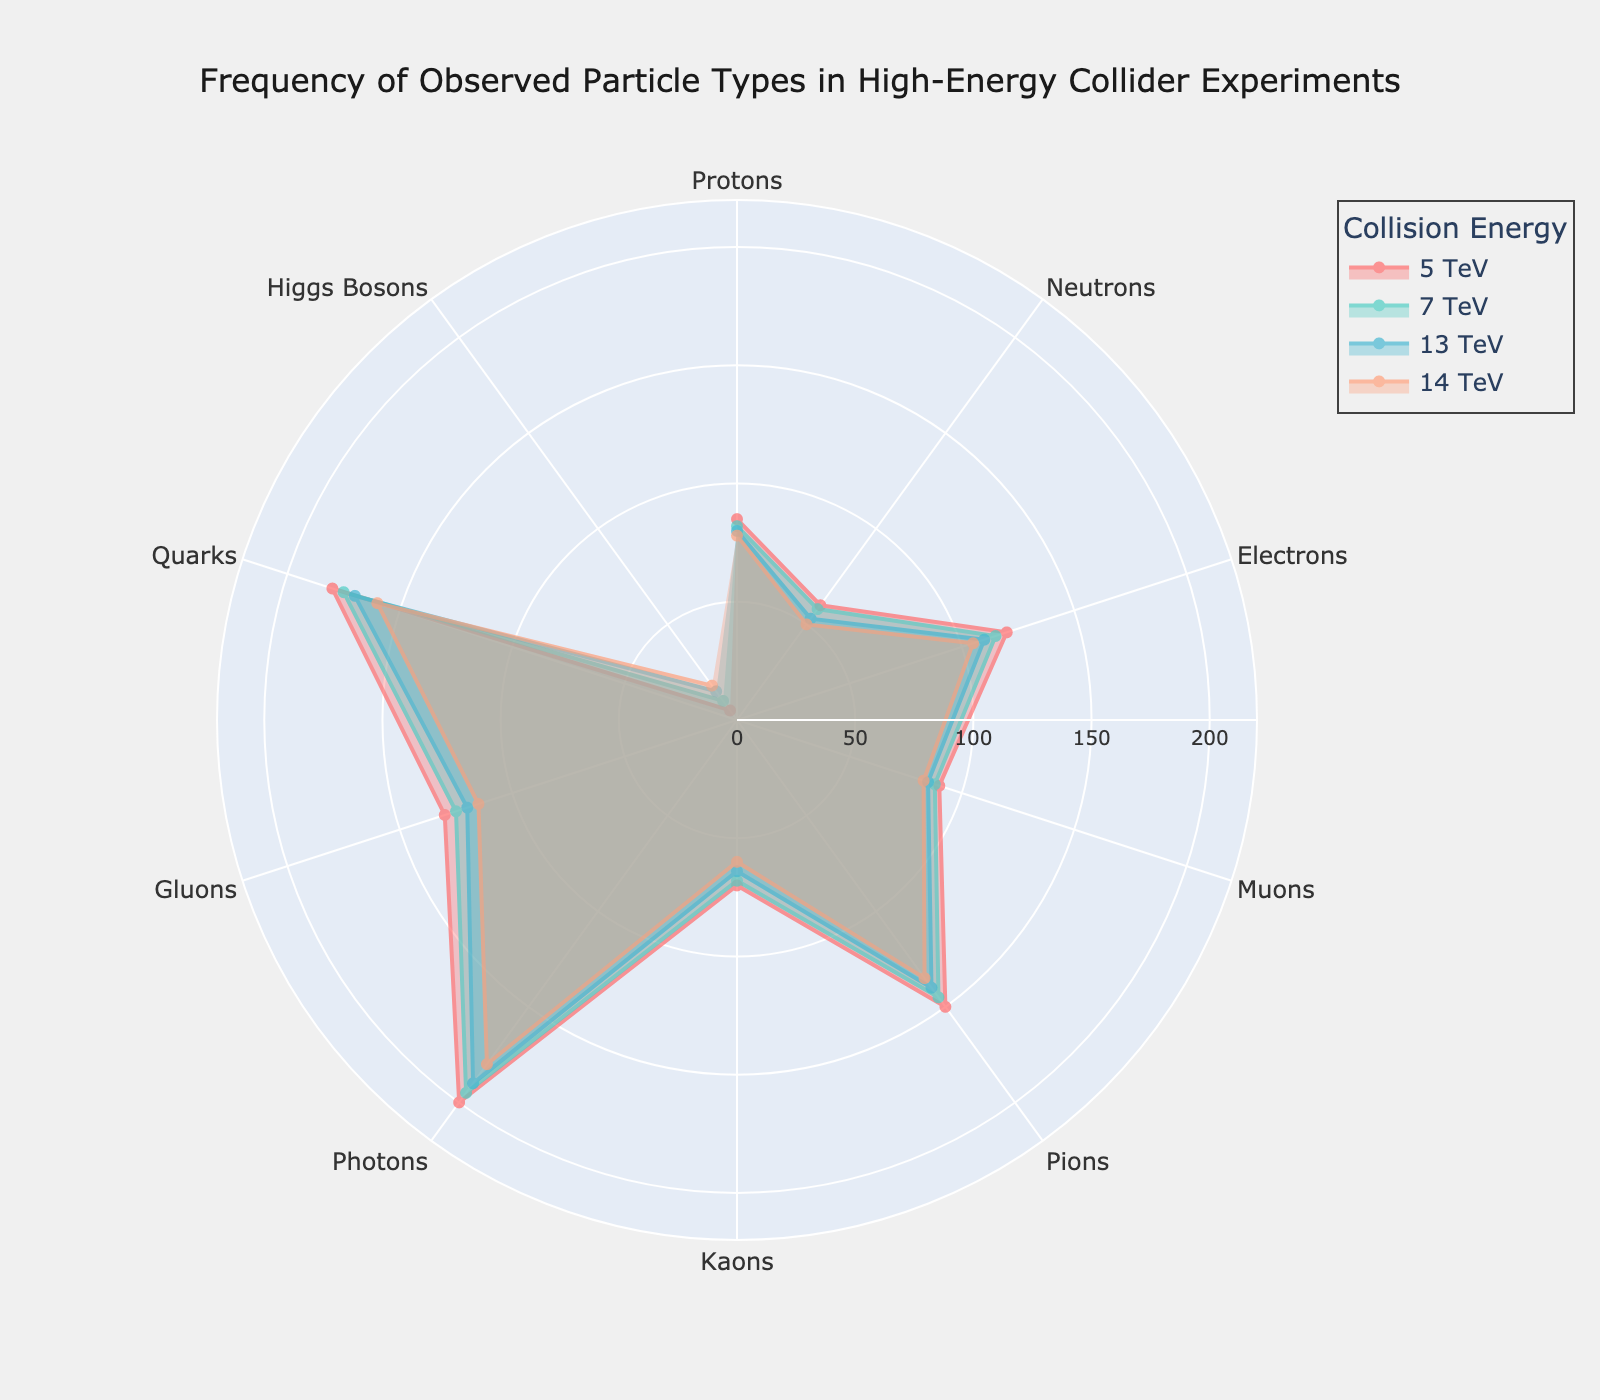What's the title of the figure? The title is usually displayed at the top of the figure. It provides a brief description of what the figure illustrates. In this case, it should indicate the data being visualized.
Answer: Frequency of Observed Particle Types in High-Energy Collider Experiments Which particle type has the highest frequency across all energy levels? By visually inspecting the radar chart, find the particle type with the outermost point (highest value) on the radar axes.
Answer: Photons How does the frequency of Higgs Bosons change as the collision energy increases? Observe the positions of Higgs Bosons on the radar chart for each energy level and note the trend. The frequency increases as the collision energy rises.
Answer: Increases Which two particle types have the most similar frequencies at 14 TeV? Compare the positions of particle types at the 14 TeV axis to find the two that are closest.
Answer: Neutrons and Kaons What is the combined frequency of Protons and Electrons at 7 TeV? Find the frequencies of each particle at 7 TeV and add them together: 82 (Protons) + 115 (Electrons).
Answer: 197 Are Pions more or less frequent than Quarks at 13 TeV? Look at the values for Pions and Quarks at 13 TeV on the radar chart and determine which is higher.
Answer: Less frequent What's the difference in frequency between Muons and Gluons at 5 TeV? Locate the frequencies of Muons and Gluons at 5 TeV and subtract one from the other: 130 (Gluons) - 90 (Muons).
Answer: 40 Which energy level shows the minimum frequency for Neutrons? Compare the Neutron frequencies across all energy levels to find the minimum value.
Answer: 14 TeV On average, which particle type shows the least frequency across all energy levels? Calculate the average frequency for each particle type across all energy levels and identify the one with the lowest average.
Answer: Higgs Bosons 